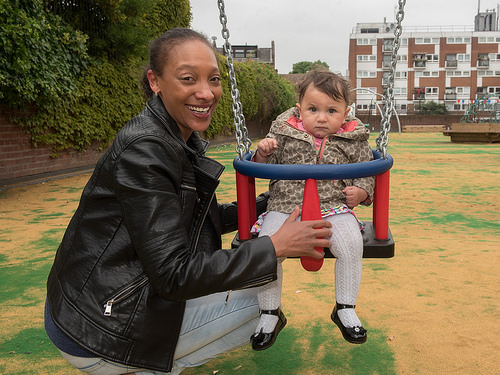<image>
Is there a kid behind the adult? No. The kid is not behind the adult. From this viewpoint, the kid appears to be positioned elsewhere in the scene. Where is the woman in relation to the baby? Is it behind the baby? No. The woman is not behind the baby. From this viewpoint, the woman appears to be positioned elsewhere in the scene. Is the kid above the ground? Yes. The kid is positioned above the ground in the vertical space, higher up in the scene. 